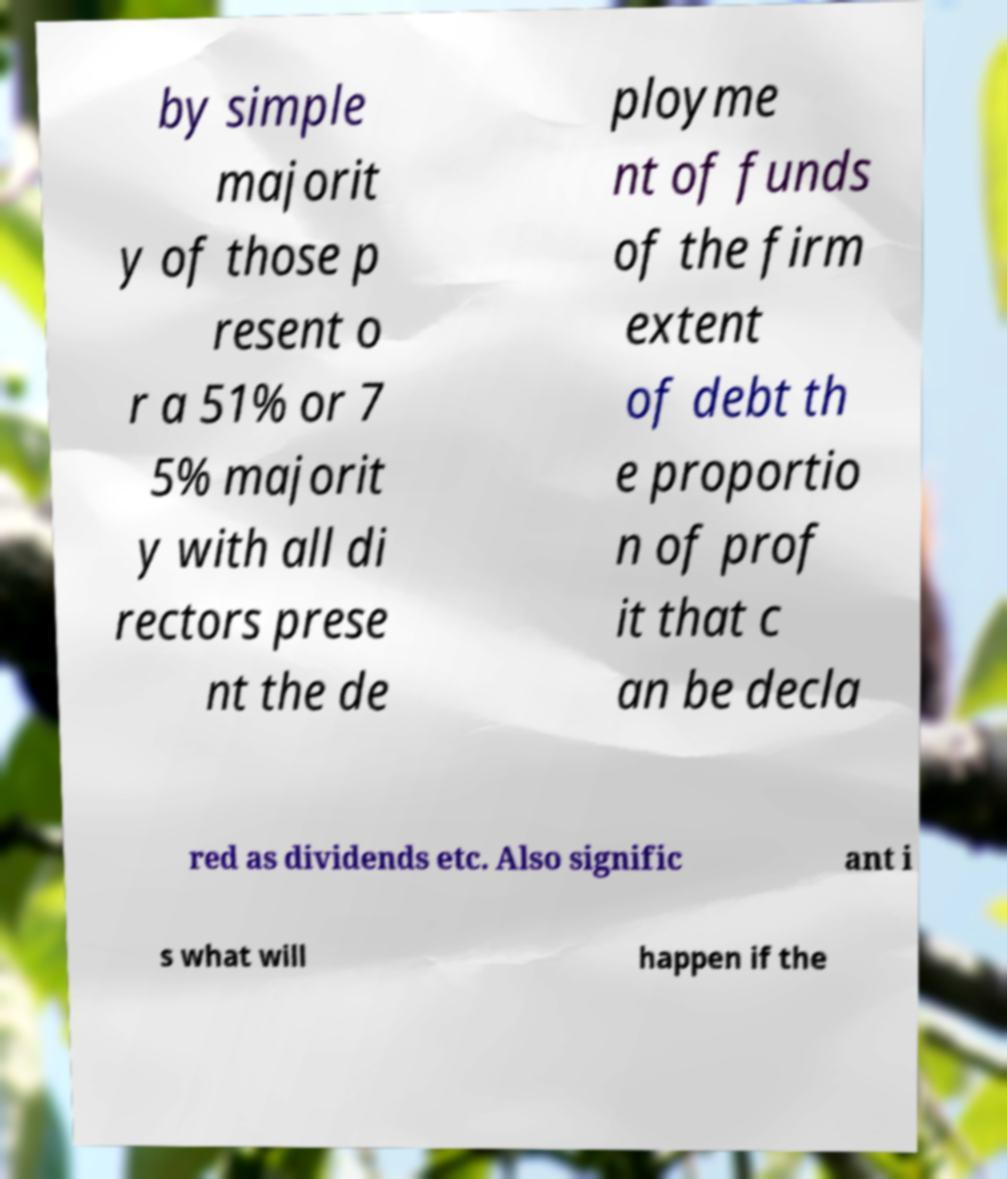Can you accurately transcribe the text from the provided image for me? by simple majorit y of those p resent o r a 51% or 7 5% majorit y with all di rectors prese nt the de ployme nt of funds of the firm extent of debt th e proportio n of prof it that c an be decla red as dividends etc. Also signific ant i s what will happen if the 